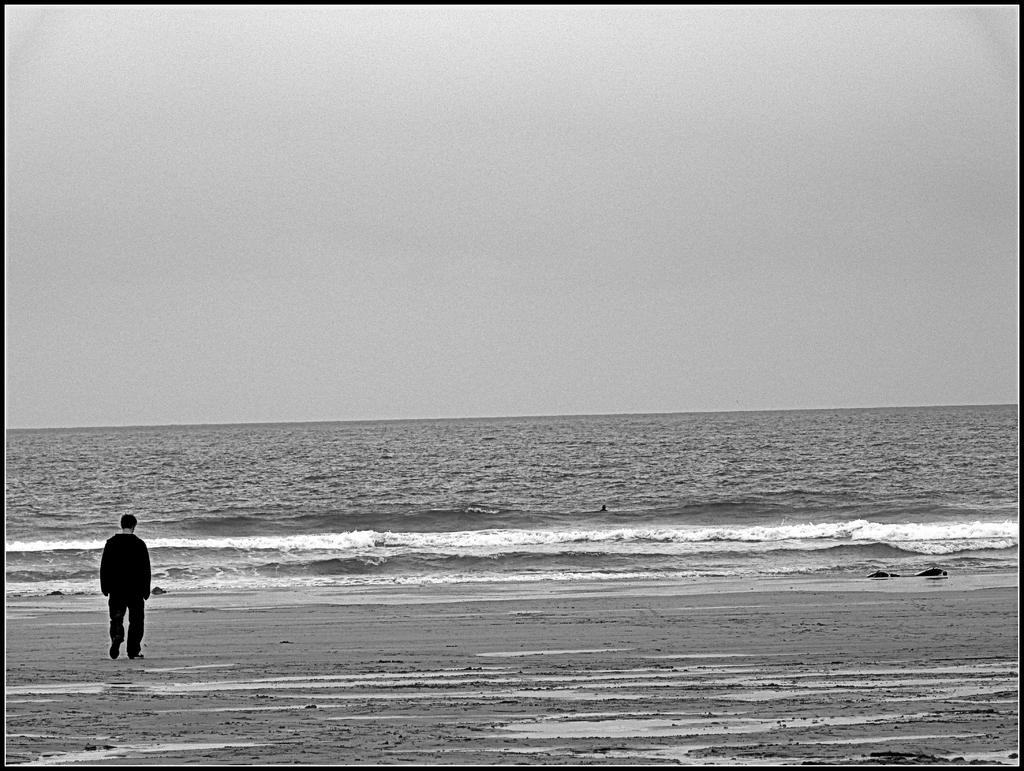What is the color scheme of the image? The image is black and white. What can be seen in the image? There is a person standing in the image. Where is the person standing? The person is standing on the seashore. What is visible in the background of the image? The sky is visible in the background of the image. What type of produce is the robin eating in the image? There is no robin or produce present in the image. What story is the person telling while standing on the seashore? The image does not provide any information about a story being told by the person standing on the seashore. 